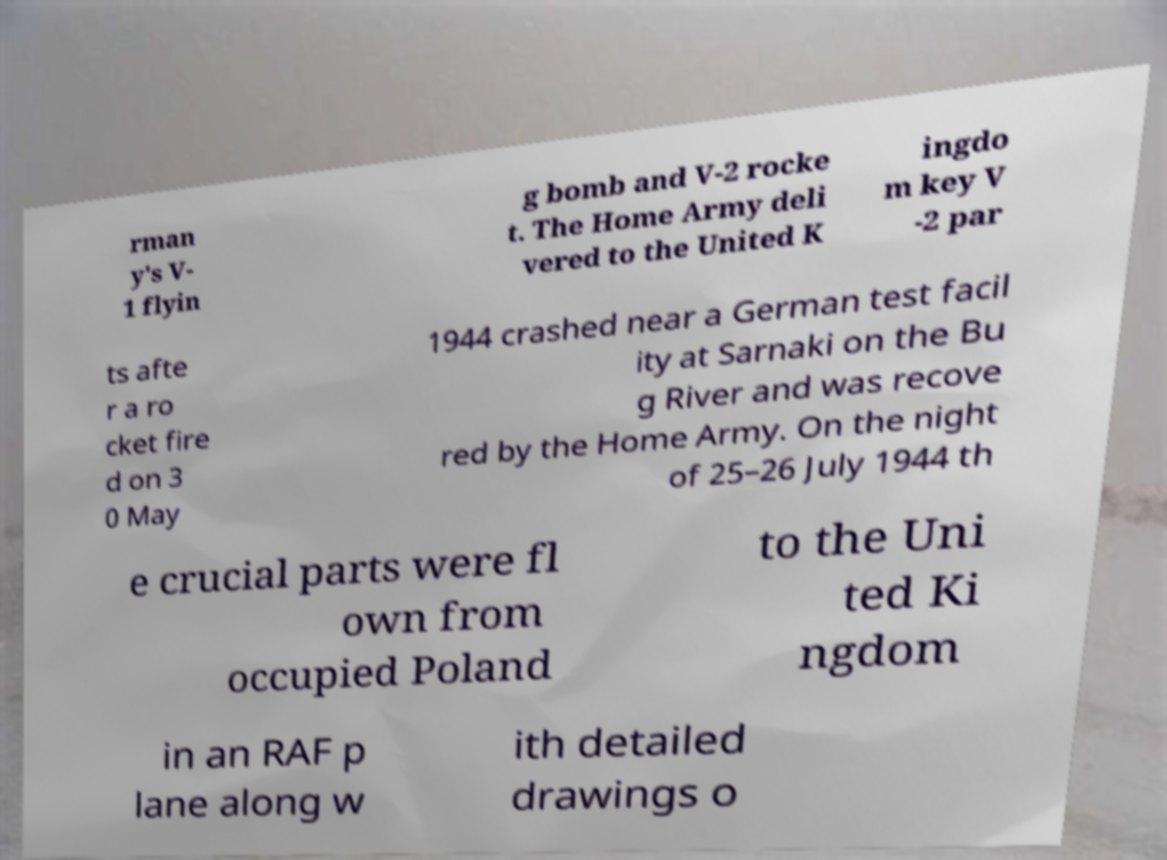Please read and relay the text visible in this image. What does it say? rman y's V- 1 flyin g bomb and V-2 rocke t. The Home Army deli vered to the United K ingdo m key V -2 par ts afte r a ro cket fire d on 3 0 May 1944 crashed near a German test facil ity at Sarnaki on the Bu g River and was recove red by the Home Army. On the night of 25–26 July 1944 th e crucial parts were fl own from occupied Poland to the Uni ted Ki ngdom in an RAF p lane along w ith detailed drawings o 